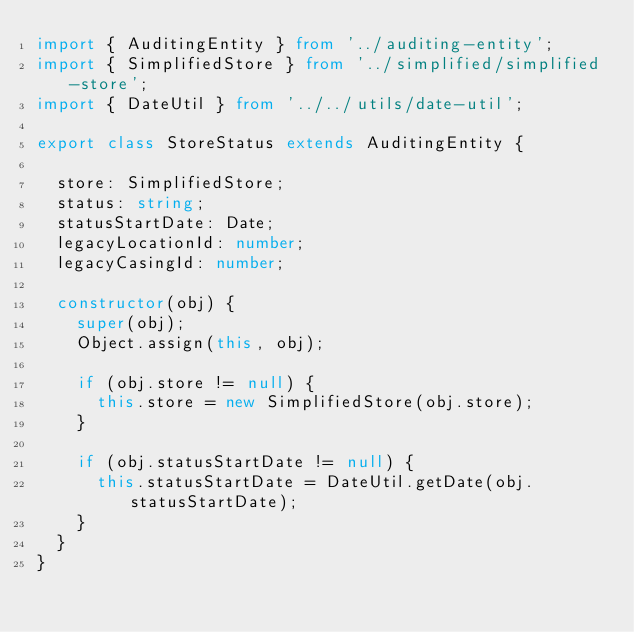<code> <loc_0><loc_0><loc_500><loc_500><_TypeScript_>import { AuditingEntity } from '../auditing-entity';
import { SimplifiedStore } from '../simplified/simplified-store';
import { DateUtil } from '../../utils/date-util';

export class StoreStatus extends AuditingEntity {

  store: SimplifiedStore;
  status: string;
  statusStartDate: Date;
  legacyLocationId: number;
  legacyCasingId: number;

  constructor(obj) {
    super(obj);
    Object.assign(this, obj);

    if (obj.store != null) {
      this.store = new SimplifiedStore(obj.store);
    }

    if (obj.statusStartDate != null) {
      this.statusStartDate = DateUtil.getDate(obj.statusStartDate);
    }
  }
}
</code> 